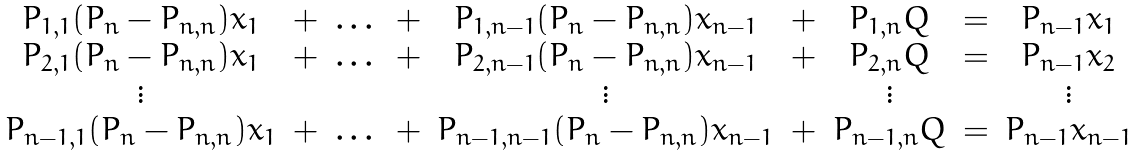Convert formula to latex. <formula><loc_0><loc_0><loc_500><loc_500>\begin{array} { c c c c c c c c c } P _ { 1 , 1 } ( P _ { n } - P _ { n , n } ) x _ { 1 } & + & \dots & + & P _ { 1 , n - 1 } ( P _ { n } - P _ { n , n } ) x _ { n - 1 } & + & P _ { 1 , n } Q & = & P _ { n - 1 } x _ { 1 } \\ P _ { 2 , 1 } ( P _ { n } - P _ { n , n } ) x _ { 1 } & + & \dots & + & P _ { 2 , n - 1 } ( P _ { n } - P _ { n , n } ) x _ { n - 1 } & + & P _ { 2 , n } Q & = & P _ { n - 1 } x _ { 2 } \\ \vdots & & & & \vdots & & \vdots & & \vdots \\ P _ { n - 1 , 1 } ( P _ { n } - P _ { n , n } ) x _ { 1 } & + & \dots & + & P _ { n - 1 , n - 1 } ( P _ { n } - P _ { n , n } ) x _ { n - 1 } & + & P _ { n - 1 , n } Q & = & P _ { n - 1 } x _ { n - 1 } \end{array}</formula> 